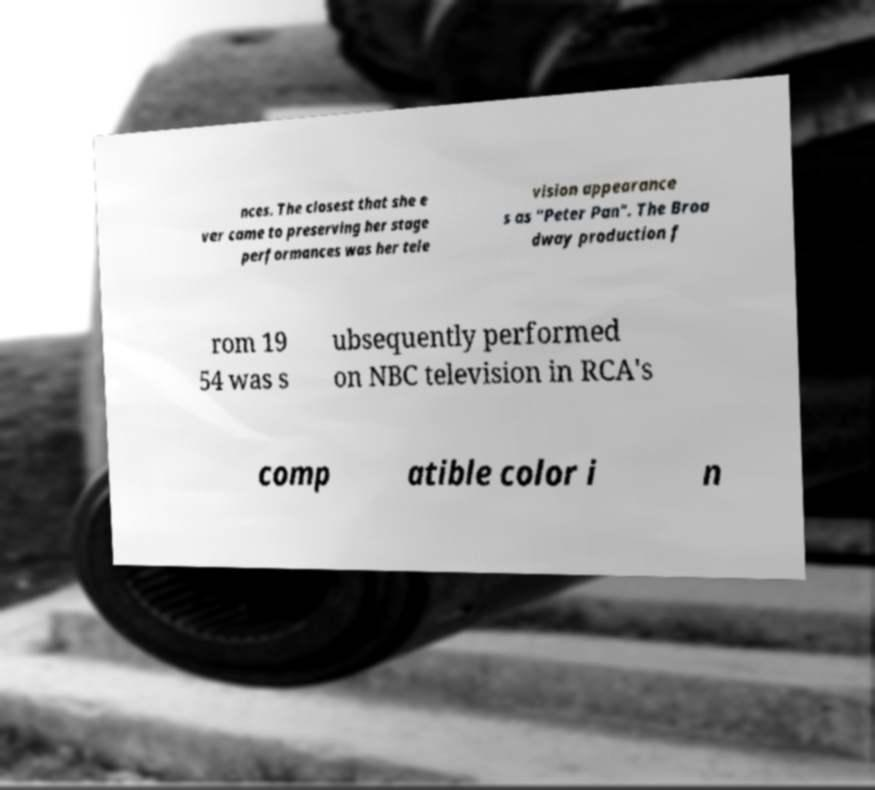Please read and relay the text visible in this image. What does it say? nces. The closest that she e ver came to preserving her stage performances was her tele vision appearance s as "Peter Pan". The Broa dway production f rom 19 54 was s ubsequently performed on NBC television in RCA's comp atible color i n 